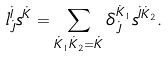Convert formula to latex. <formula><loc_0><loc_0><loc_500><loc_500>l ^ { \dot { I } } _ { \dot { J } } s ^ { \dot { K } } = \sum _ { \dot { K } _ { 1 } \dot { K } _ { 2 } = \dot { K } } \delta ^ { \dot { K } _ { 1 } } _ { \dot { J } } s ^ { \dot { I } \dot { K } _ { 2 } } .</formula> 